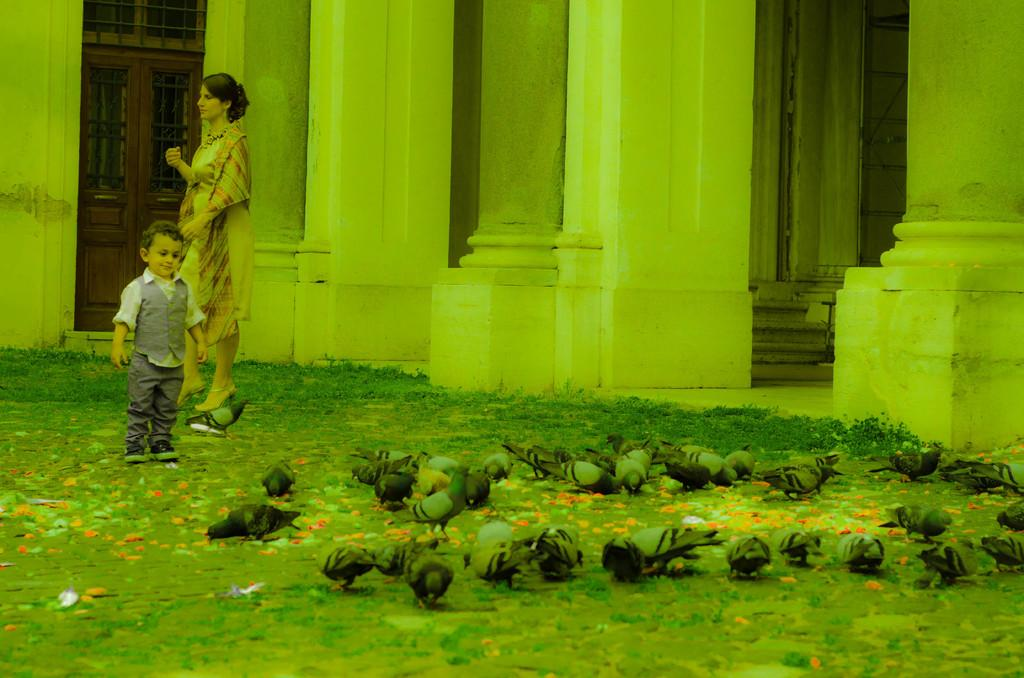What type of animals can be seen in the image? There are pigeons in the image. What are the people in the image doing? The persons standing on the ground in the image are not performing any specific action. What architectural features can be seen in the background of the image? There are stairs, pillars, and a door with grills in the background of the image. What is the current temperature in the image? There is no information about the temperature in the image. Can you tell me the weight of the crow in the image? There are no crows present in the image. 